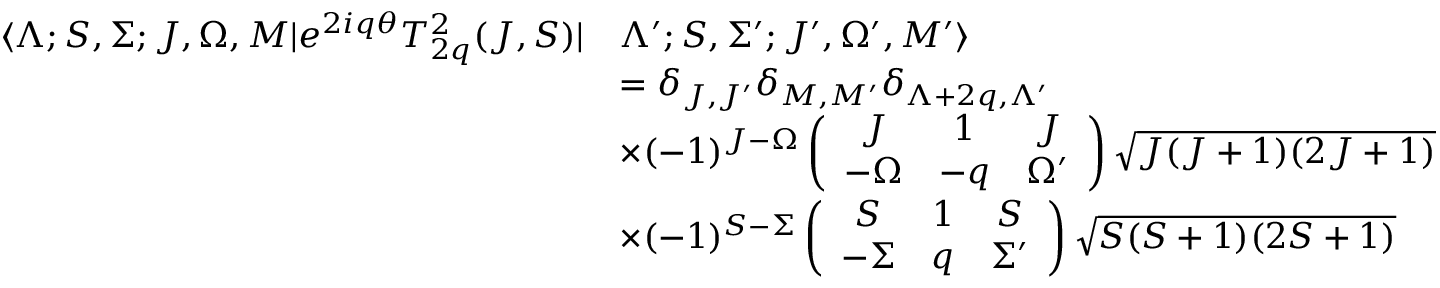Convert formula to latex. <formula><loc_0><loc_0><loc_500><loc_500>\begin{array} { r l } { \langle \Lambda ; S , \Sigma ; J , \Omega , M | e ^ { 2 i q \theta } T _ { 2 q } ^ { 2 } ( J , S ) | } & { \Lambda ^ { \prime } ; S , \Sigma ^ { \prime } ; J ^ { \prime } , \Omega ^ { \prime } , M ^ { \prime } \rangle } \\ & { = \delta _ { J , J ^ { \prime } } \delta _ { M , M ^ { \prime } } \delta _ { \Lambda + 2 q , \Lambda ^ { \prime } } } \\ & { \times ( - 1 ) ^ { J - \Omega } \left ( \begin{array} { c c c } { J } & { 1 } & { J } \\ { - \Omega } & { - q } & { \Omega ^ { \prime } } \end{array} \right ) \sqrt { J ( J + 1 ) ( 2 J + 1 ) } } \\ & { \times ( - 1 ) ^ { S - \Sigma } \left ( \begin{array} { c c c } { S } & { 1 } & { S } \\ { - \Sigma } & { q } & { \Sigma ^ { \prime } } \end{array} \right ) \sqrt { S ( S + 1 ) ( 2 S + 1 ) } } \end{array}</formula> 